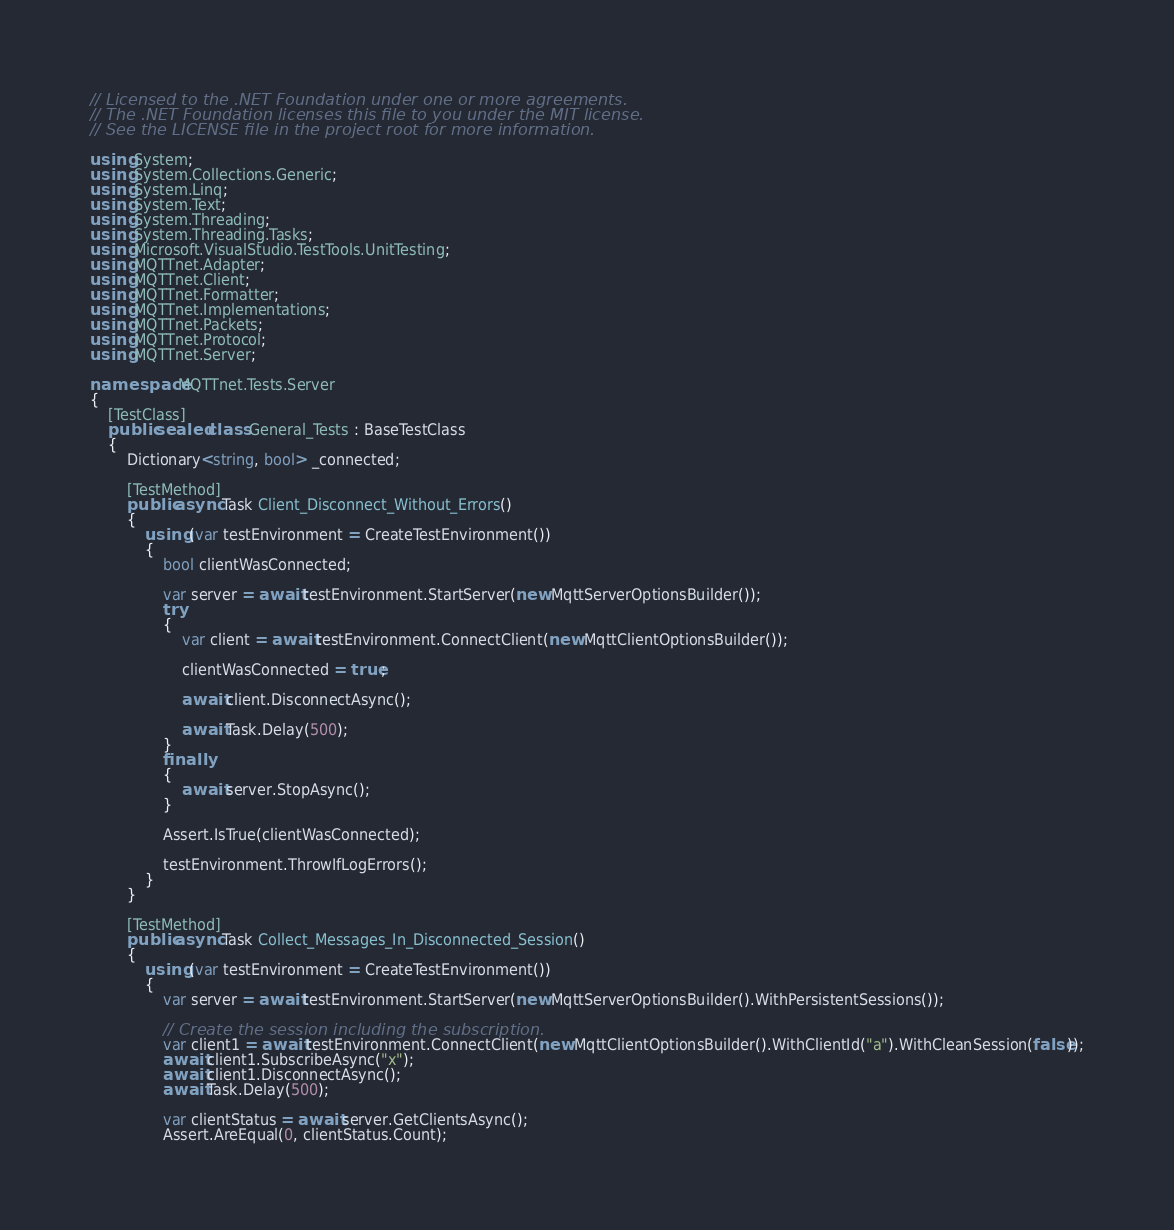<code> <loc_0><loc_0><loc_500><loc_500><_C#_>// Licensed to the .NET Foundation under one or more agreements.
// The .NET Foundation licenses this file to you under the MIT license.
// See the LICENSE file in the project root for more information.

using System;
using System.Collections.Generic;
using System.Linq;
using System.Text;
using System.Threading;
using System.Threading.Tasks;
using Microsoft.VisualStudio.TestTools.UnitTesting;
using MQTTnet.Adapter;
using MQTTnet.Client;
using MQTTnet.Formatter;
using MQTTnet.Implementations;
using MQTTnet.Packets;
using MQTTnet.Protocol;
using MQTTnet.Server;

namespace MQTTnet.Tests.Server
{
    [TestClass]
    public sealed class General_Tests : BaseTestClass
    {
        Dictionary<string, bool> _connected;

        [TestMethod]
        public async Task Client_Disconnect_Without_Errors()
        {
            using (var testEnvironment = CreateTestEnvironment())
            {
                bool clientWasConnected;

                var server = await testEnvironment.StartServer(new MqttServerOptionsBuilder());
                try
                {
                    var client = await testEnvironment.ConnectClient(new MqttClientOptionsBuilder());

                    clientWasConnected = true;

                    await client.DisconnectAsync();

                    await Task.Delay(500);
                }
                finally
                {
                    await server.StopAsync();
                }

                Assert.IsTrue(clientWasConnected);

                testEnvironment.ThrowIfLogErrors();
            }
        }

        [TestMethod]
        public async Task Collect_Messages_In_Disconnected_Session()
        {
            using (var testEnvironment = CreateTestEnvironment())
            {
                var server = await testEnvironment.StartServer(new MqttServerOptionsBuilder().WithPersistentSessions());

                // Create the session including the subscription.
                var client1 = await testEnvironment.ConnectClient(new MqttClientOptionsBuilder().WithClientId("a").WithCleanSession(false));
                await client1.SubscribeAsync("x");
                await client1.DisconnectAsync();
                await Task.Delay(500);

                var clientStatus = await server.GetClientsAsync();
                Assert.AreEqual(0, clientStatus.Count);
</code> 